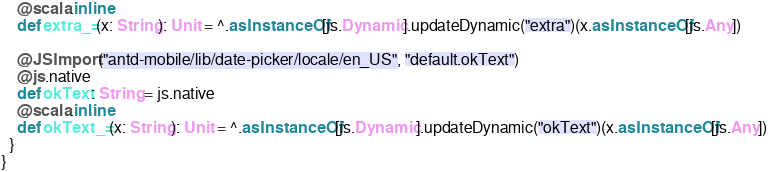<code> <loc_0><loc_0><loc_500><loc_500><_Scala_>    @scala.inline
    def extra_=(x: String): Unit = ^.asInstanceOf[js.Dynamic].updateDynamic("extra")(x.asInstanceOf[js.Any])
    
    @JSImport("antd-mobile/lib/date-picker/locale/en_US", "default.okText")
    @js.native
    def okText: String = js.native
    @scala.inline
    def okText_=(x: String): Unit = ^.asInstanceOf[js.Dynamic].updateDynamic("okText")(x.asInstanceOf[js.Any])
  }
}
</code> 